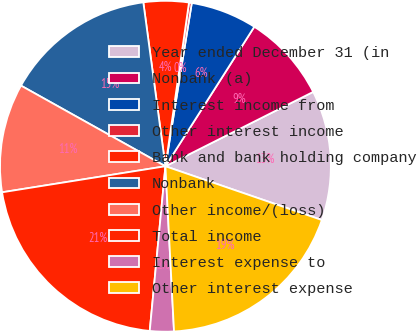Convert chart. <chart><loc_0><loc_0><loc_500><loc_500><pie_chart><fcel>Year ended December 31 (in<fcel>Nonbank (a)<fcel>Interest income from<fcel>Other interest income<fcel>Bank and bank holding company<fcel>Nonbank<fcel>Other income/(loss)<fcel>Total income<fcel>Interest expense to<fcel>Other interest expense<nl><fcel>12.69%<fcel>8.55%<fcel>6.48%<fcel>0.27%<fcel>4.41%<fcel>14.76%<fcel>10.62%<fcel>20.97%<fcel>2.34%<fcel>18.9%<nl></chart> 